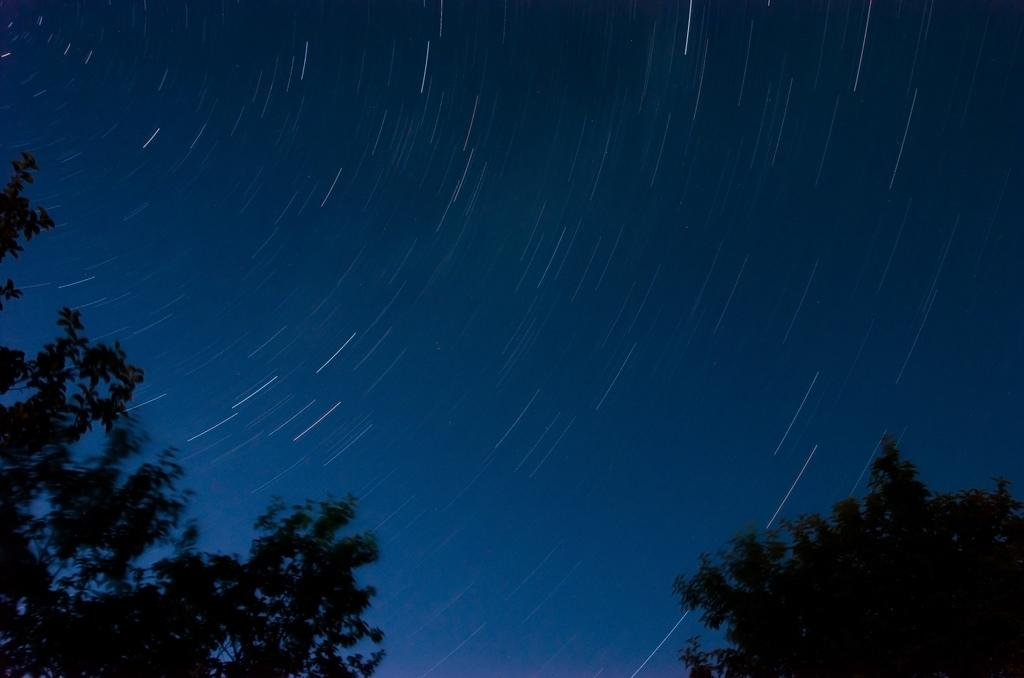What type of vegetation can be seen in the image? There are trees in the image. What part of the natural environment is visible in the image? The sky is visible in the background of the image. What type of feather can be seen on the tree in the image? There is no feather present on the tree in the image. What ornament is hanging from the branches of the tree in the image? There is no ornament hanging from the branches of the tree in the image. 